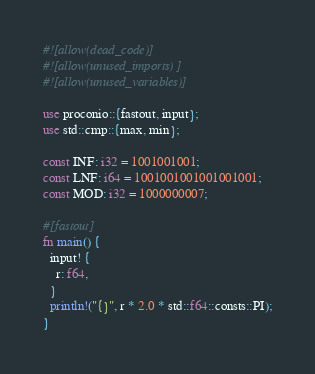Convert code to text. <code><loc_0><loc_0><loc_500><loc_500><_Rust_>#![allow(dead_code)]
#![allow(unused_imports)]
#![allow(unused_variables)]

use proconio::{fastout, input};
use std::cmp::{max, min};

const INF: i32 = 1001001001;
const LNF: i64 = 1001001001001001001;
const MOD: i32 = 1000000007;

#[fastout]
fn main() {
  input! {
    r: f64,
  }
  println!("{}", r * 2.0 * std::f64::consts::PI);
}
</code> 